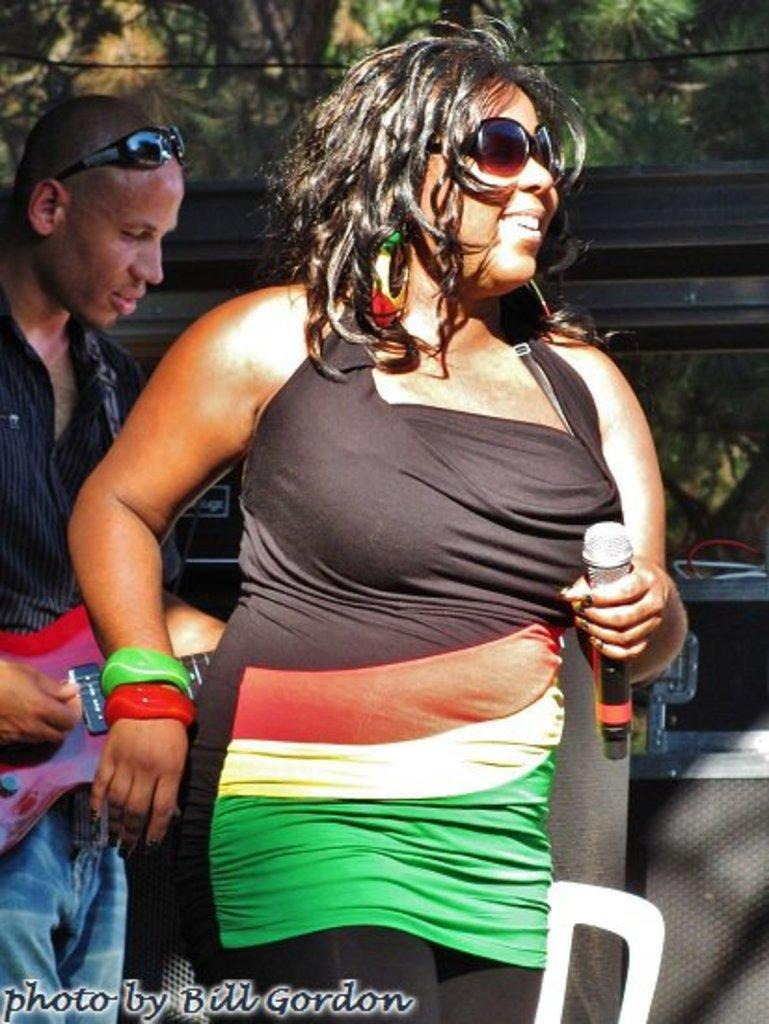Who are the people in the image? There is a woman and a man in the image. What is the man doing in the image? The man is playing a guitar. What is the woman holding in the image? The woman is holding a microphone. What can be seen in the background of the image? There are trees in the background of the image. How many apples can be seen on the monkey's head in the image? There is no monkey or apples present in the image. 